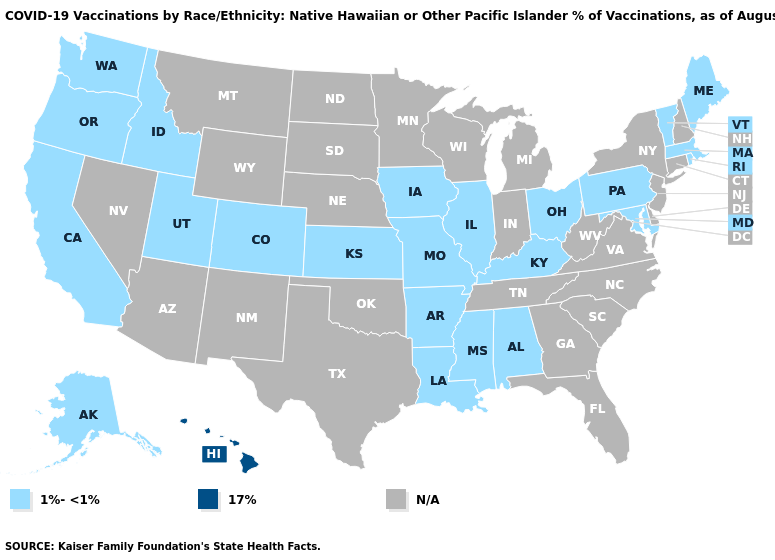Name the states that have a value in the range 17%?
Write a very short answer. Hawaii. What is the value of Ohio?
Short answer required. 1%-<1%. What is the highest value in the USA?
Write a very short answer. 17%. Is the legend a continuous bar?
Quick response, please. No. Does Oregon have the highest value in the West?
Be succinct. No. Does Hawaii have the highest value in the West?
Short answer required. Yes. Does the first symbol in the legend represent the smallest category?
Answer briefly. Yes. Name the states that have a value in the range 1%-<1%?
Concise answer only. Alabama, Alaska, Arkansas, California, Colorado, Idaho, Illinois, Iowa, Kansas, Kentucky, Louisiana, Maine, Maryland, Massachusetts, Mississippi, Missouri, Ohio, Oregon, Pennsylvania, Rhode Island, Utah, Vermont, Washington. Does Iowa have the lowest value in the USA?
Concise answer only. Yes. What is the value of Kentucky?
Concise answer only. 1%-<1%. 